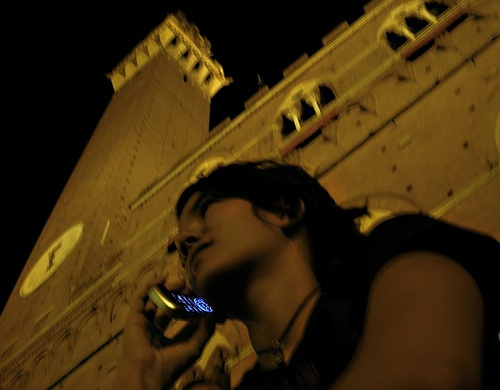Describe the objects in this image and their specific colors. I can see people in black, maroon, and olive tones, cell phone in black, olive, navy, and blue tones, and clock in black, olive, and maroon tones in this image. 